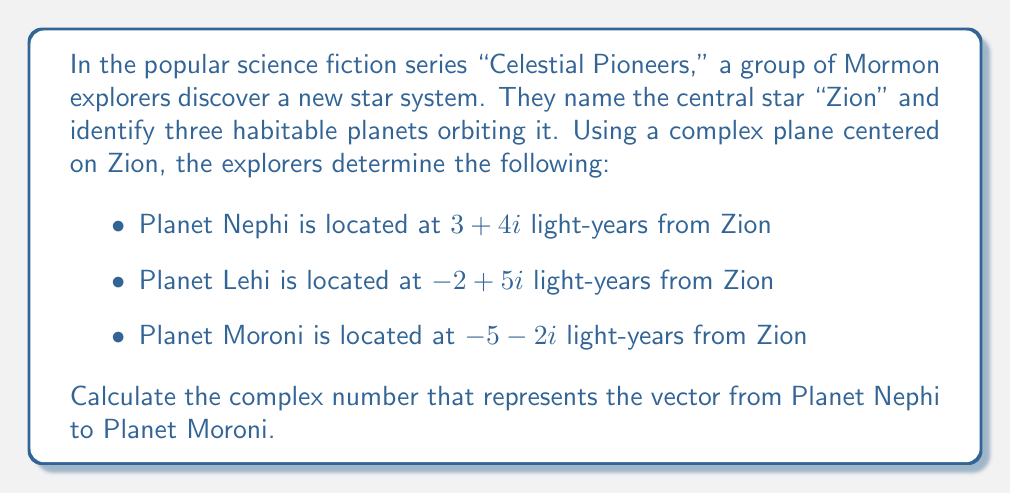Give your solution to this math problem. To find the vector from Planet Nephi to Planet Moroni, we need to subtract the complex coordinate of Nephi from that of Moroni. This is because a vector is defined as the displacement from one point to another.

Let's break it down step by step:

1. Coordinate of Planet Nephi: $z_1 = 3 + 4i$
2. Coordinate of Planet Moroni: $z_2 = -5 - 2i$

The vector from Nephi to Moroni is given by:

$$\vec{v} = z_2 - z_1$$

Substituting the values:

$$\begin{align}
\vec{v} &= (-5 - 2i) - (3 + 4i) \\
&= -5 - 2i - 3 - 4i \\
&= -8 - 6i
\end{align}$$

This complex number represents the direction and distance from Planet Nephi to Planet Moroni in the Zion star system.

To interpret this result:
- The real part (-8) represents the displacement along the real axis (in light-years).
- The imaginary part (-6i) represents the displacement along the imaginary axis (in light-years).
Answer: $-8 - 6i$ light-years 